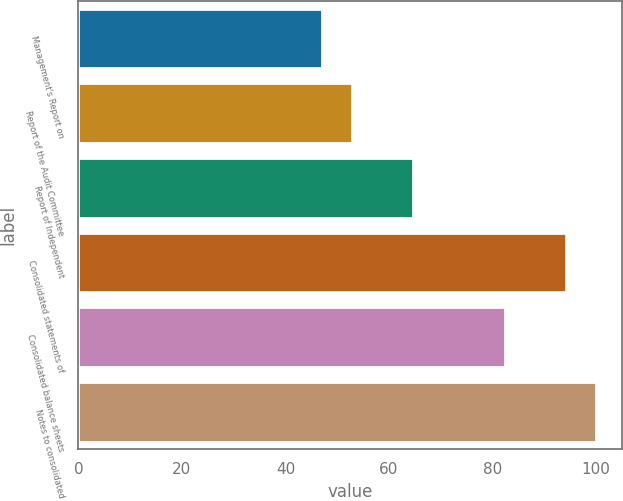<chart> <loc_0><loc_0><loc_500><loc_500><bar_chart><fcel>Management's Report on<fcel>Report of the Audit Committee<fcel>Report of Independent<fcel>Consolidated statements of<fcel>Consolidated balance sheets<fcel>Notes to consolidated<nl><fcel>47<fcel>52.9<fcel>64.7<fcel>94.2<fcel>82.4<fcel>100.1<nl></chart> 